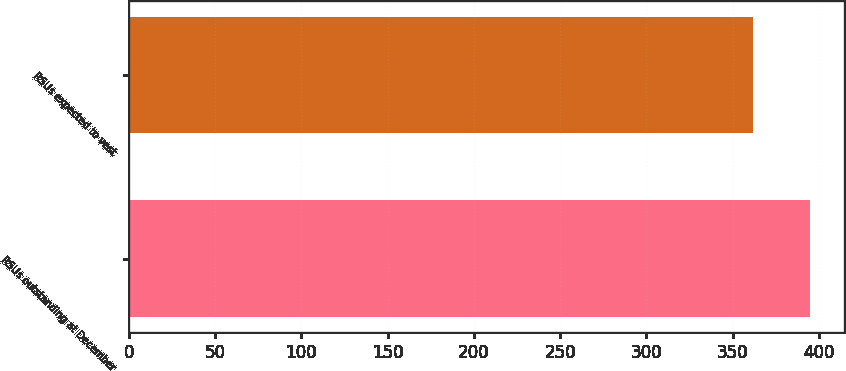Convert chart. <chart><loc_0><loc_0><loc_500><loc_500><bar_chart><fcel>RSUs outstanding at December<fcel>RSUs expected to vest<nl><fcel>395<fcel>362<nl></chart> 